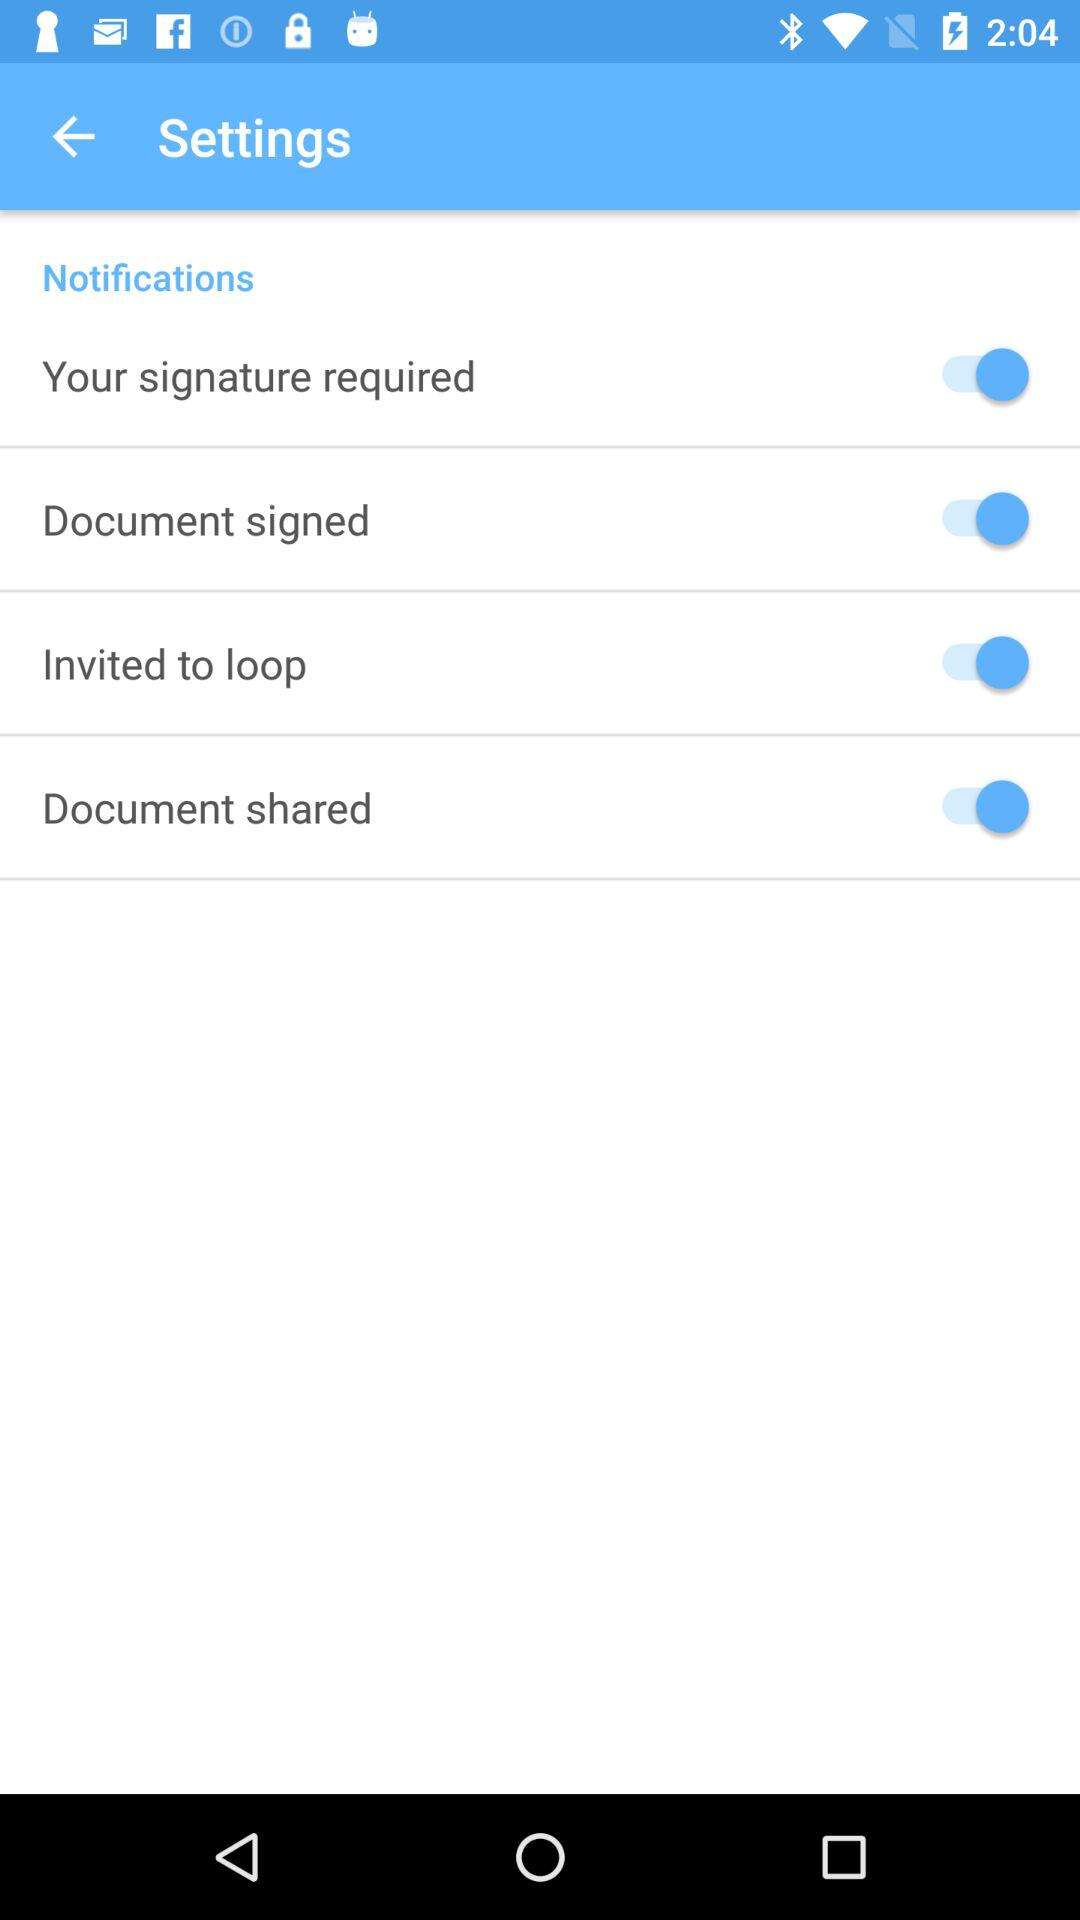What is the status of "Your signature required"? The status is "on". 